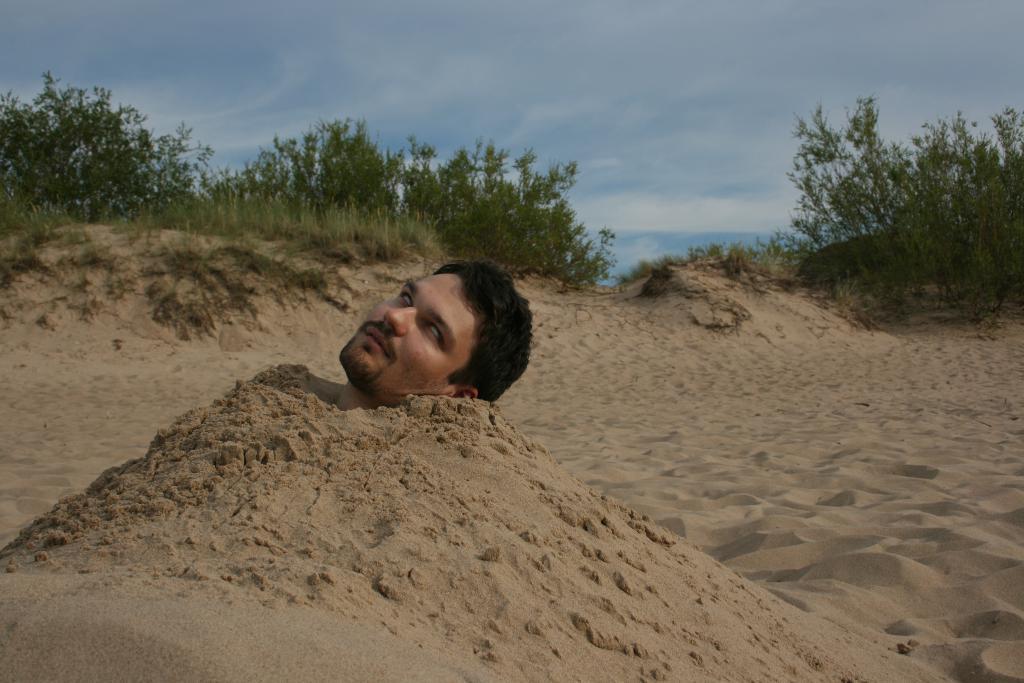In one or two sentences, can you explain what this image depicts? There is one man is in the sand, we can see in the middle of this image, and there are trees in the background. There is a sky at the top of this image. 